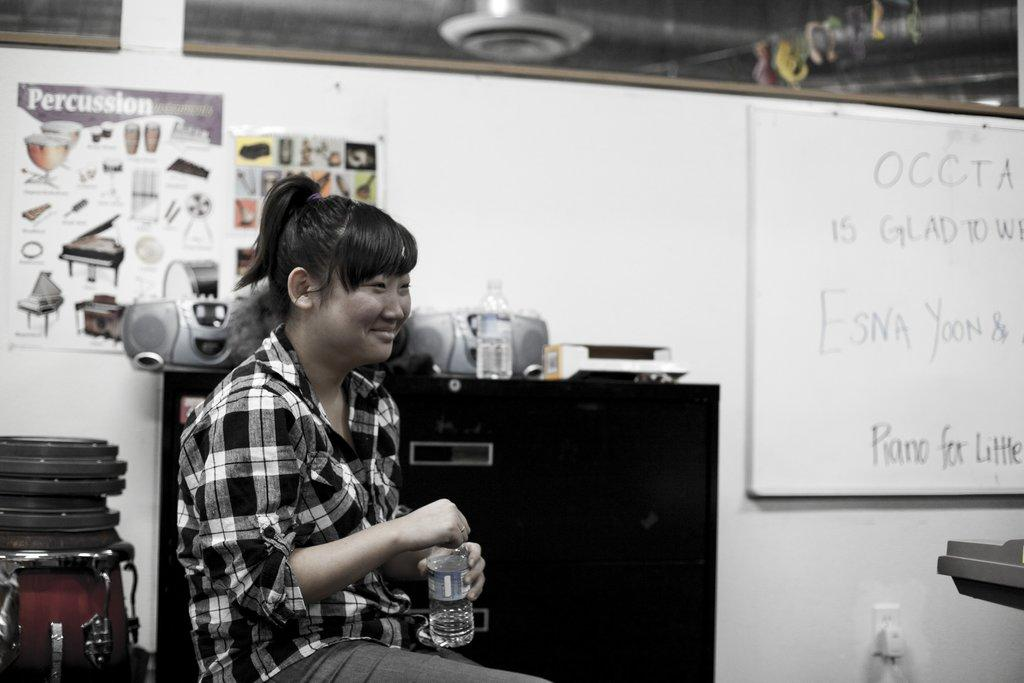Provide a one-sentence caption for the provided image. Woman sitting in a classroom with a poster titled Percussion behind her. 